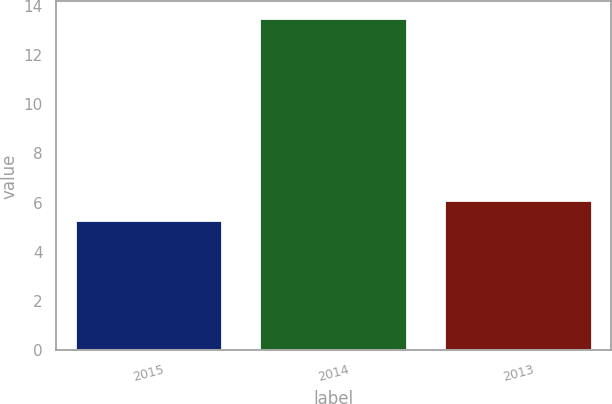Convert chart to OTSL. <chart><loc_0><loc_0><loc_500><loc_500><bar_chart><fcel>2015<fcel>2014<fcel>2013<nl><fcel>5.3<fcel>13.5<fcel>6.12<nl></chart> 